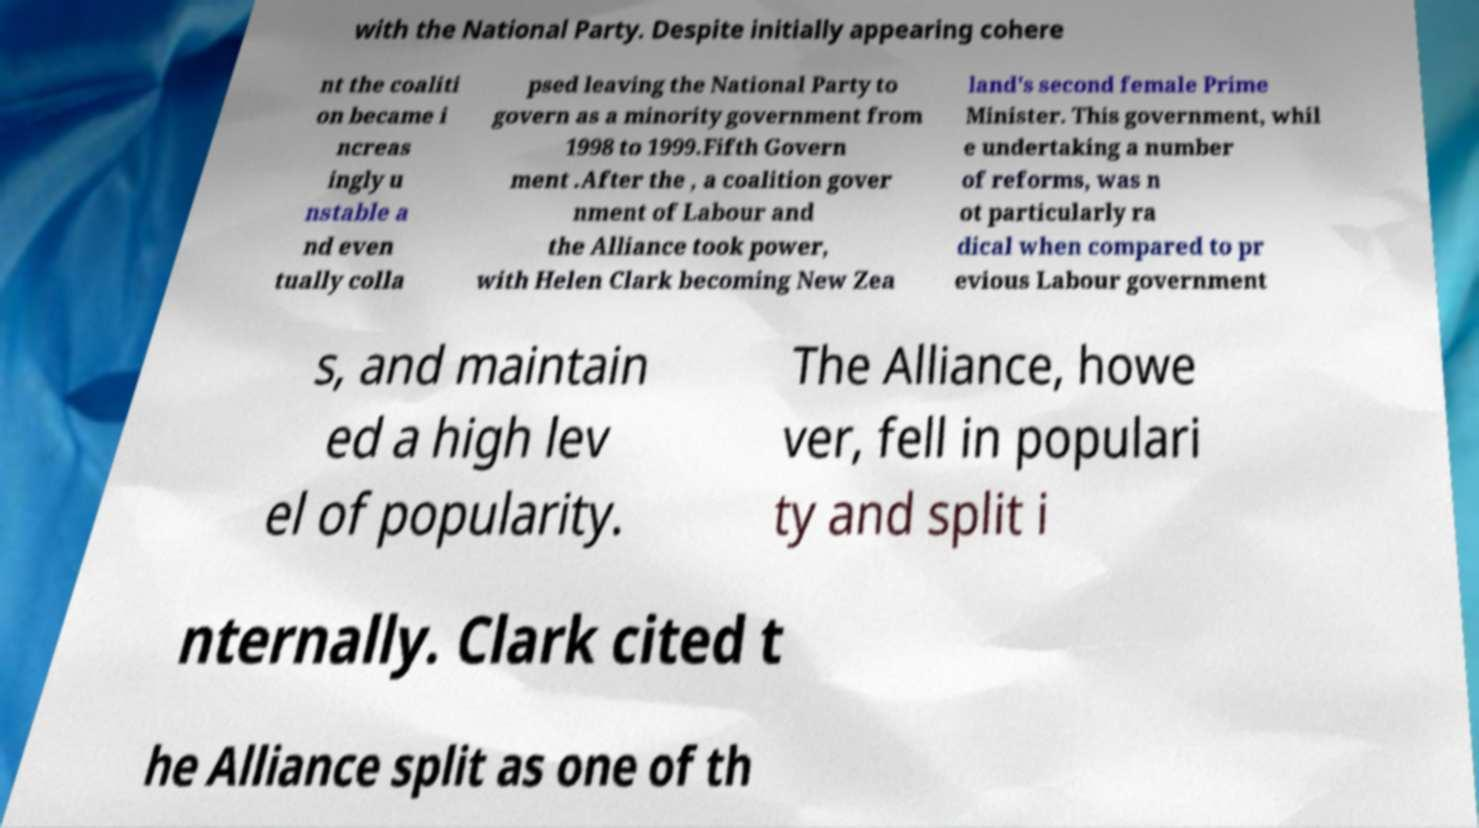Could you extract and type out the text from this image? with the National Party. Despite initially appearing cohere nt the coaliti on became i ncreas ingly u nstable a nd even tually colla psed leaving the National Party to govern as a minority government from 1998 to 1999.Fifth Govern ment .After the , a coalition gover nment of Labour and the Alliance took power, with Helen Clark becoming New Zea land's second female Prime Minister. This government, whil e undertaking a number of reforms, was n ot particularly ra dical when compared to pr evious Labour government s, and maintain ed a high lev el of popularity. The Alliance, howe ver, fell in populari ty and split i nternally. Clark cited t he Alliance split as one of th 